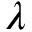<formula> <loc_0><loc_0><loc_500><loc_500>\lambda</formula> 